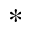<formula> <loc_0><loc_0><loc_500><loc_500>^ { \ast }</formula> 